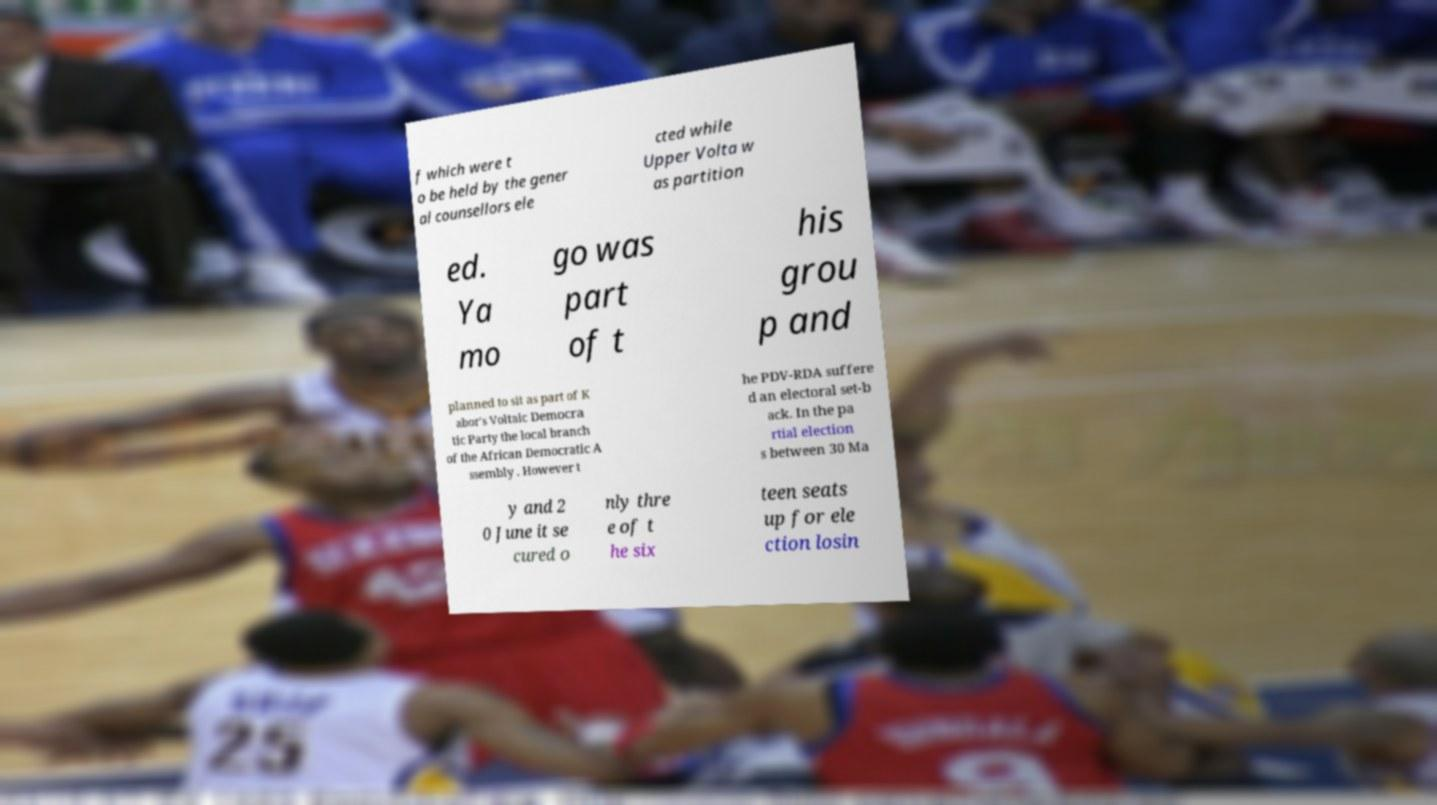Could you extract and type out the text from this image? f which were t o be held by the gener al counsellors ele cted while Upper Volta w as partition ed. Ya mo go was part of t his grou p and planned to sit as part of K abor's Voltaic Democra tic Party the local branch of the African Democratic A ssembly . However t he PDV-RDA suffere d an electoral set-b ack. In the pa rtial election s between 30 Ma y and 2 0 June it se cured o nly thre e of t he six teen seats up for ele ction losin 